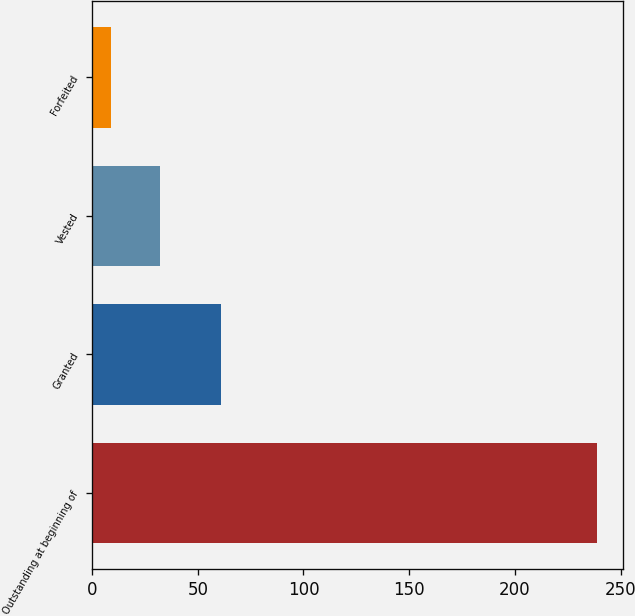Convert chart to OTSL. <chart><loc_0><loc_0><loc_500><loc_500><bar_chart><fcel>Outstanding at beginning of<fcel>Granted<fcel>Vested<fcel>Forfeited<nl><fcel>239<fcel>61<fcel>32<fcel>9<nl></chart> 